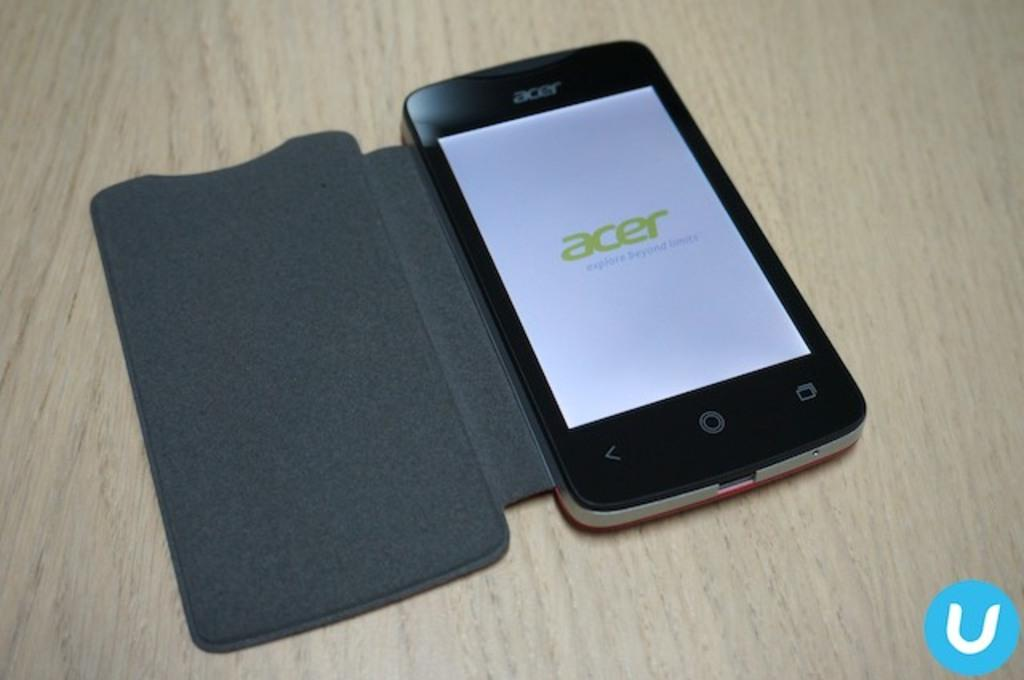Provide a one-sentence caption for the provided image. An Acer phone is turned on a sitting on a table with the cover open. 